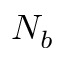Convert formula to latex. <formula><loc_0><loc_0><loc_500><loc_500>N _ { b }</formula> 